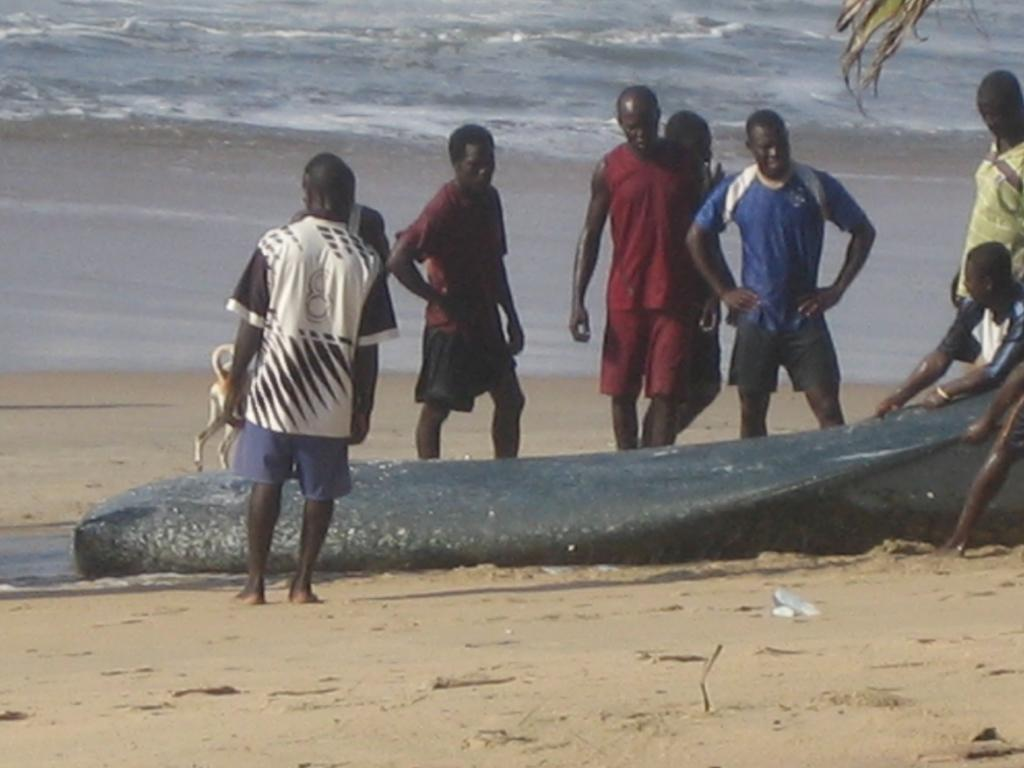What is the setting of the image? The people are standing in the sea shore. Are there any animals present with the people? Yes, a dog is present with the people. What are some people holding in the image? Some people are holding a net. What can be seen inside the net? There are fishes visible in the net. What type of drink is being served to the people in the image? There is no drink present in the image; the people are standing in the sea shore and holding a net with fishes. 